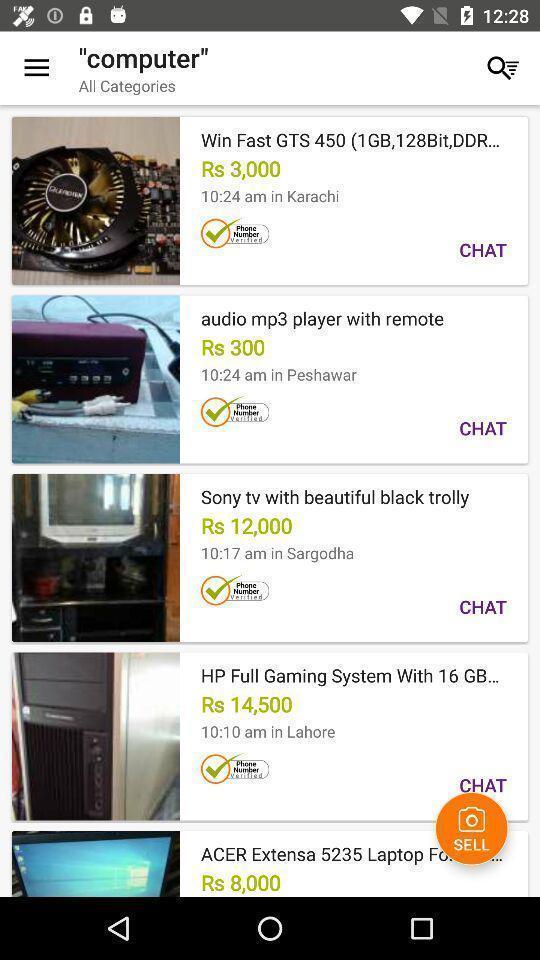Tell me about the visual elements in this screen capture. Page showing the computer products for sale. 